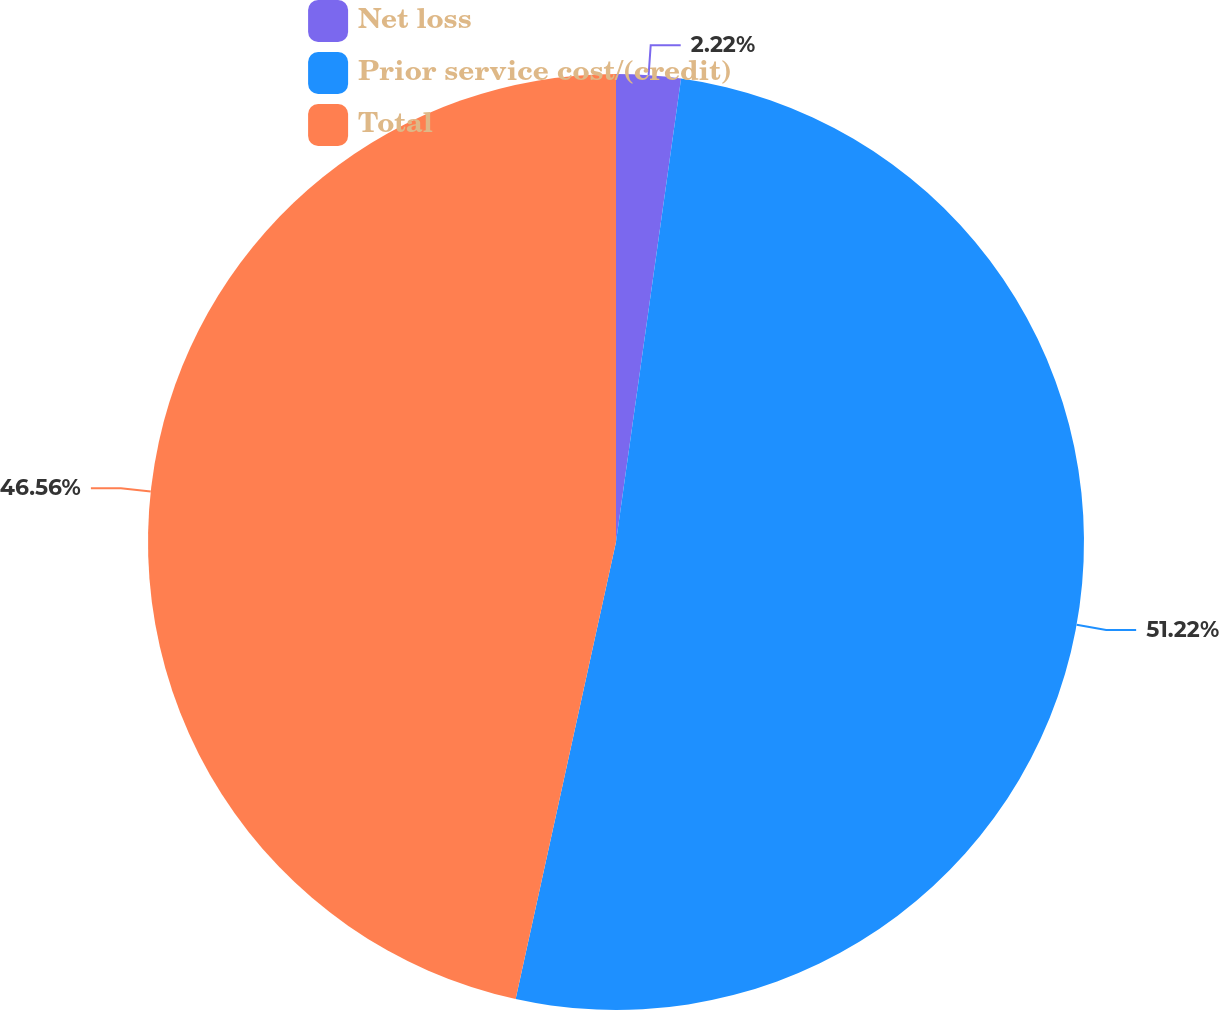Convert chart to OTSL. <chart><loc_0><loc_0><loc_500><loc_500><pie_chart><fcel>Net loss<fcel>Prior service cost/(credit)<fcel>Total<nl><fcel>2.22%<fcel>51.22%<fcel>46.56%<nl></chart> 